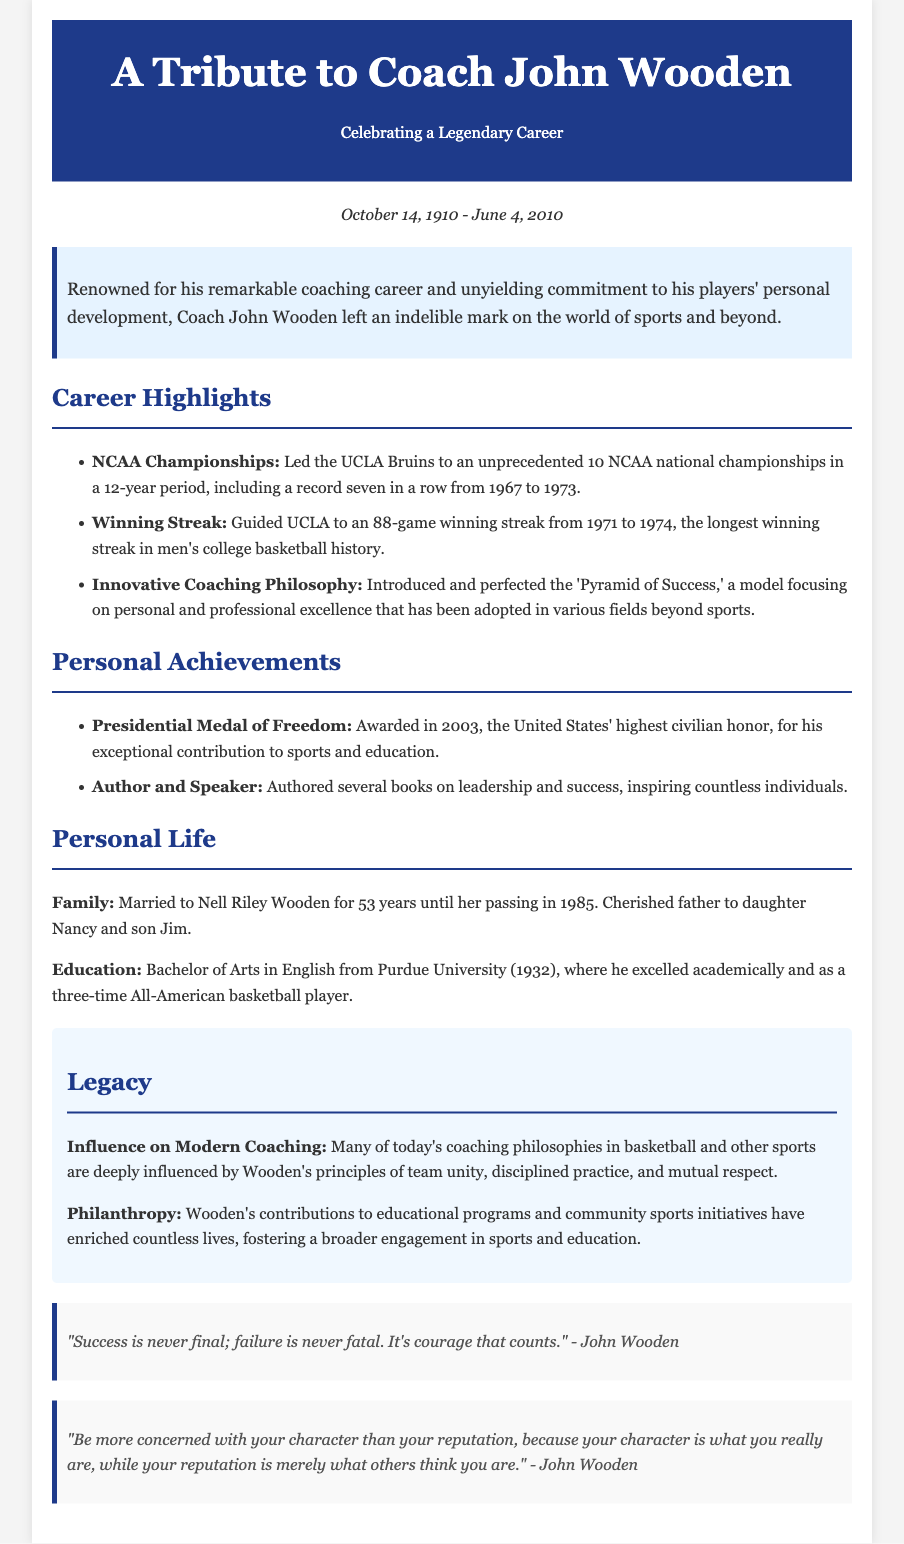What years did Coach John Wooden win NCAA Championships? The document states that he won 10 NCAA national championships in a 12-year period, including seven in a row from 1967 to 1973.
Answer: 1967 to 1973 How long was Coach Wooden’s winning streak at UCLA? The document mentions that UCLA had an 88-game winning streak from 1971 to 1974.
Answer: 88 games What prestigious award did Coach Wooden receive in 2003? The text specifies that he was awarded the Presidential Medal of Freedom in 2003.
Answer: Presidential Medal of Freedom What educational qualification did Coach Wooden achieve from Purdue University? It is stated in the document that he obtained a Bachelor of Arts in English from Purdue University.
Answer: Bachelor of Arts in English How many years was Coach Wooden married to Nell Riley Wooden? The document mentions they were married for 53 years until her passing in 1985.
Answer: 53 years What principle did Coach Wooden introduce that is mentioned in the document? The document highlights the 'Pyramid of Success' as an innovative coaching philosophy introduced by Wooden.
Answer: Pyramid of Success What is the notable quote about success attributed to Coach Wooden? A quote in the document states, "Success is never final; failure is never fatal. It's courage that counts."
Answer: Success is never final; failure is never fatal. It's courage that counts What main influence does Coach Wooden's legacy have according to the document? The document notes that many modern coaching philosophies in sports are influenced by Wooden's principles.
Answer: Modern coaching philosophies 